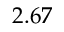<formula> <loc_0><loc_0><loc_500><loc_500>2 . 6 7</formula> 